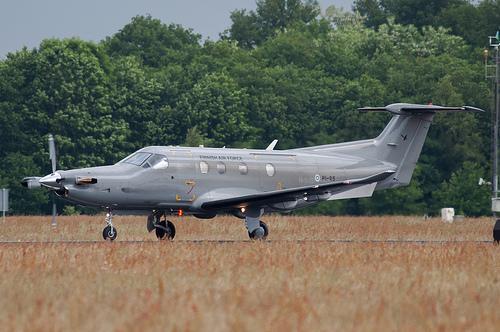How many planes are there?
Give a very brief answer. 1. 